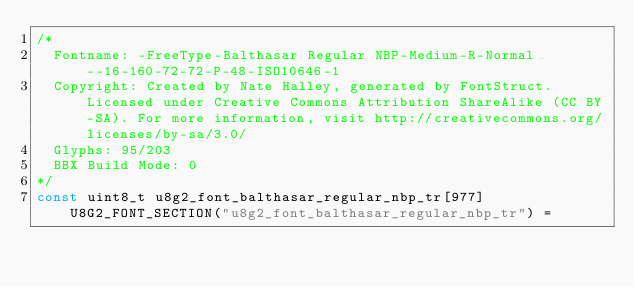Convert code to text. <code><loc_0><loc_0><loc_500><loc_500><_C_>/*
  Fontname: -FreeType-Balthasar Regular NBP-Medium-R-Normal--16-160-72-72-P-48-ISO10646-1
  Copyright: Created by Nate Halley, generated by FontStruct. Licensed under Creative Commons Attribution ShareAlike (CC BY-SA). For more information, visit http://creativecommons.org/licenses/by-sa/3.0/
  Glyphs: 95/203
  BBX Build Mode: 0
*/
const uint8_t u8g2_font_balthasar_regular_nbp_tr[977] U8G2_FONT_SECTION("u8g2_font_balthasar_regular_nbp_tr") = </code> 